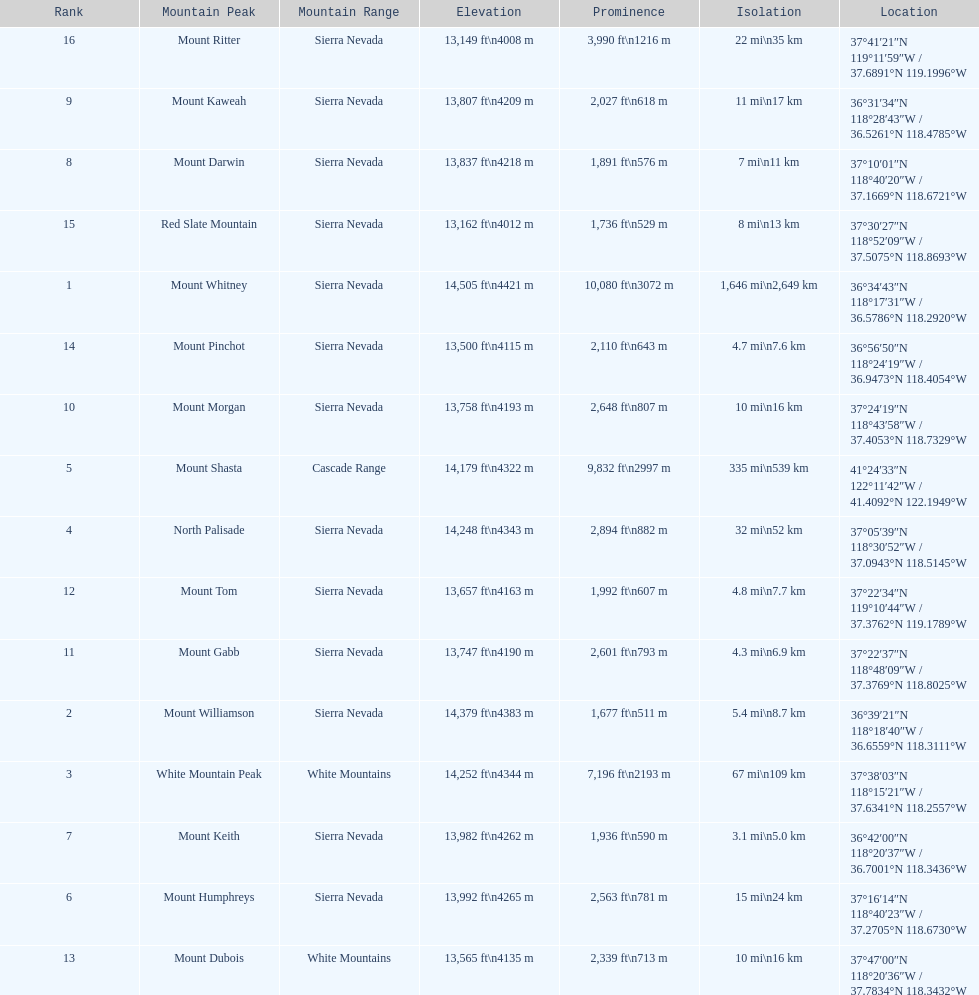Which mountain peak has the most isolation? Mount Whitney. 